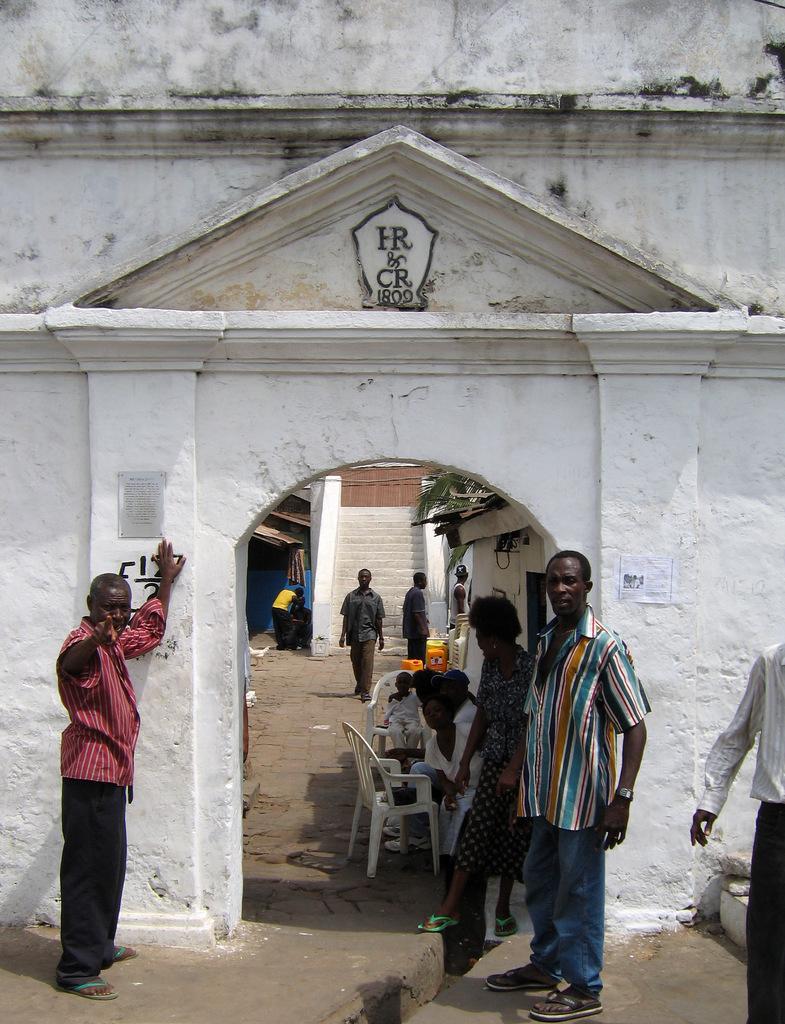Can you describe this image briefly? In this image we can see people standing. In the background of the image there are staircase. There are people walking. There are few people sitting on chairs. There is a wall with some text on it. At the bottom of the image there is floor. 